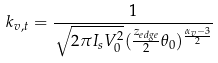<formula> <loc_0><loc_0><loc_500><loc_500>k _ { v , t } = \frac { 1 } { \sqrt { 2 \pi I _ { s } V _ { 0 } ^ { 2 } } ( \frac { z _ { e d g e } } { 2 } \theta _ { 0 } ) ^ { \frac { \alpha _ { v } - 3 } { 2 } } }</formula> 